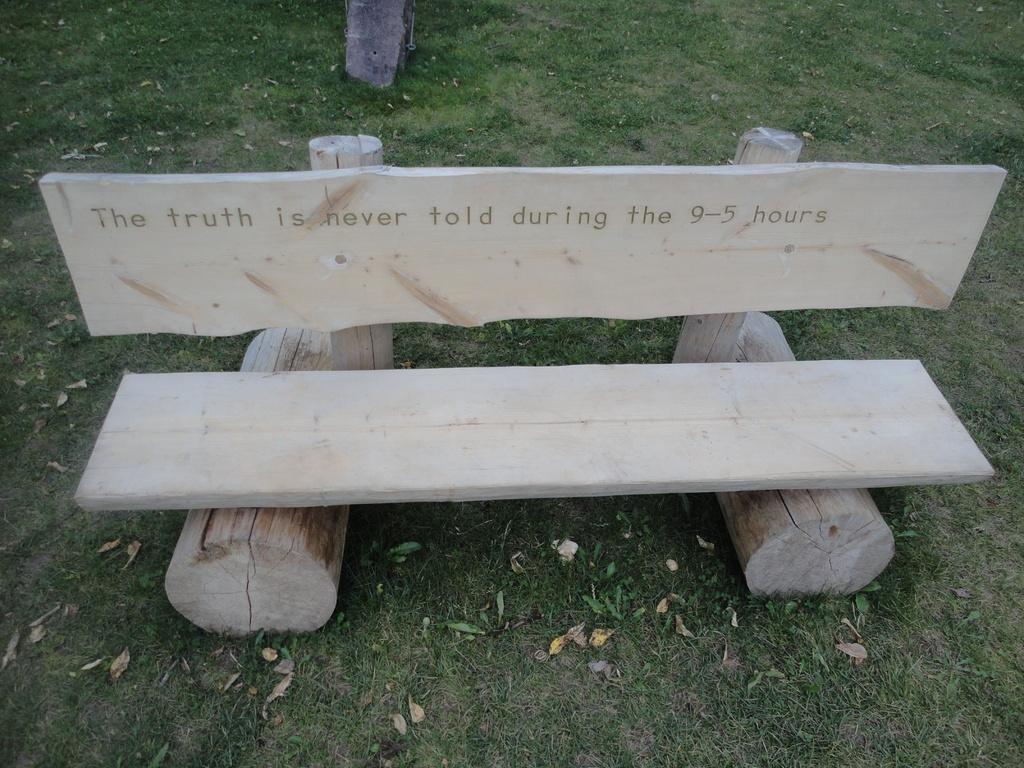What type of vegetation is present in the image? There are dry leaves and grass in the image. What type of seating is visible in the image? There is a wooden bench in the image. What part of a tree can be seen at the top of the image? There is a tree trunk visible at the top of the image. How many matches are being used to light the drum in the image? There are no matches or drums present in the image. What type of cattle can be seen grazing on the grass in the image? There are no cattle present in the image; it only features dry leaves, grass, a wooden bench, and a tree trunk. 